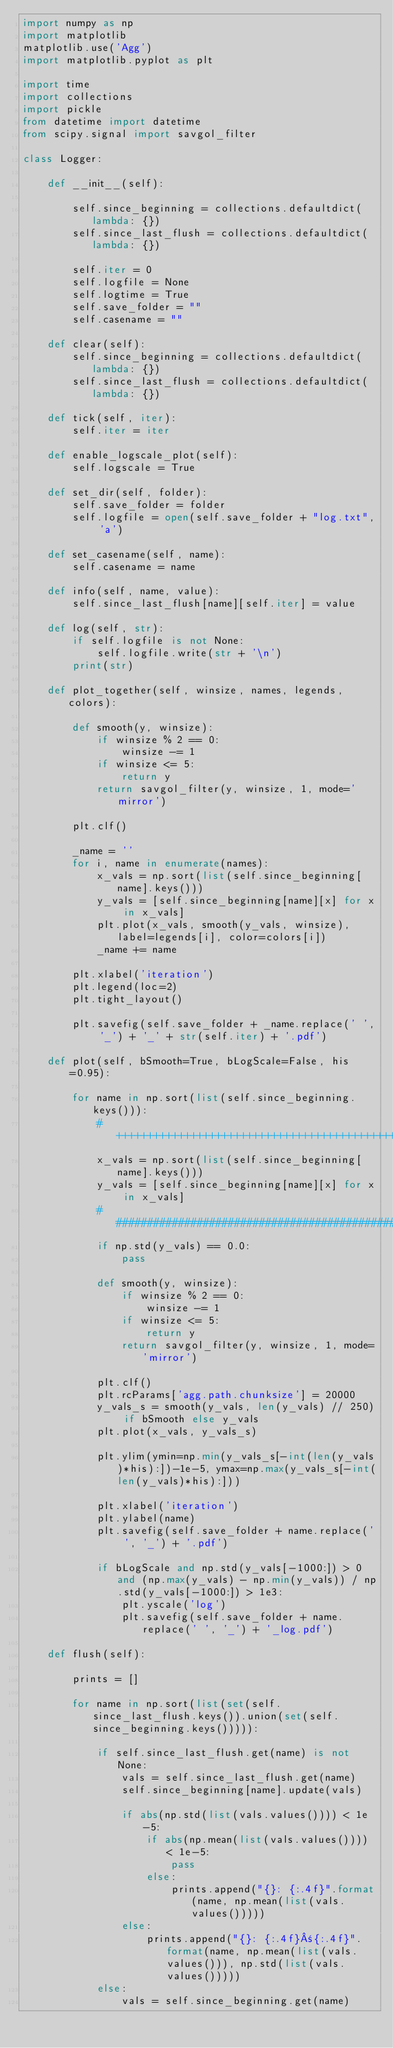<code> <loc_0><loc_0><loc_500><loc_500><_Python_>import numpy as np
import matplotlib
matplotlib.use('Agg')
import matplotlib.pyplot as plt

import time
import collections
import pickle
from datetime import datetime
from scipy.signal import savgol_filter

class Logger:

    def __init__(self):

        self.since_beginning = collections.defaultdict(lambda: {})
        self.since_last_flush = collections.defaultdict(lambda: {})

        self.iter = 0
        self.logfile = None
        self.logtime = True
        self.save_folder = ""
        self.casename = ""

    def clear(self):
        self.since_beginning = collections.defaultdict(lambda: {})
        self.since_last_flush = collections.defaultdict(lambda: {})

    def tick(self, iter):
        self.iter = iter

    def enable_logscale_plot(self):
        self.logscale = True

    def set_dir(self, folder):
        self.save_folder = folder
        self.logfile = open(self.save_folder + "log.txt", 'a')

    def set_casename(self, name):
        self.casename = name

    def info(self, name, value):
        self.since_last_flush[name][self.iter] = value

    def log(self, str):
        if self.logfile is not None:
            self.logfile.write(str + '\n')
        print(str)

    def plot_together(self, winsize, names, legends, colors):

        def smooth(y, winsize):
            if winsize % 2 == 0:
                winsize -= 1
            if winsize <= 5:
                return y
            return savgol_filter(y, winsize, 1, mode='mirror')

        plt.clf()

        _name = ''
        for i, name in enumerate(names):
            x_vals = np.sort(list(self.since_beginning[name].keys()))
            y_vals = [self.since_beginning[name][x] for x in x_vals]
            plt.plot(x_vals, smooth(y_vals, winsize), label=legends[i], color=colors[i])
            _name += name

        plt.xlabel('iteration')
        plt.legend(loc=2)
        plt.tight_layout()

        plt.savefig(self.save_folder + _name.replace(' ', '_') + '_' + str(self.iter) + '.pdf')

    def plot(self, bSmooth=True, bLogScale=False, his=0.95):

        for name in np.sort(list(self.since_beginning.keys())):
            #++++++++++++++++++++++++++++++++++++++++++++++++++++++++
            x_vals = np.sort(list(self.since_beginning[name].keys()))
            y_vals = [self.since_beginning[name][x] for x in x_vals]
            #########################################################
            if np.std(y_vals) == 0.0:
                pass

            def smooth(y, winsize):
                if winsize % 2 == 0:
                    winsize -= 1
                if winsize <= 5:
                    return y
                return savgol_filter(y, winsize, 1, mode='mirror')

            plt.clf()
            plt.rcParams['agg.path.chunksize'] = 20000
            y_vals_s = smooth(y_vals, len(y_vals) // 250) if bSmooth else y_vals
            plt.plot(x_vals, y_vals_s)

            plt.ylim(ymin=np.min(y_vals_s[-int(len(y_vals)*his):])-1e-5, ymax=np.max(y_vals_s[-int(len(y_vals)*his):]))

            plt.xlabel('iteration')
            plt.ylabel(name)
            plt.savefig(self.save_folder + name.replace(' ', '_') + '.pdf')

            if bLogScale and np.std(y_vals[-1000:]) > 0 and (np.max(y_vals) - np.min(y_vals)) / np.std(y_vals[-1000:]) > 1e3:
                plt.yscale('log')
                plt.savefig(self.save_folder + name.replace(' ', '_') + '_log.pdf')

    def flush(self):

        prints = []

        for name in np.sort(list(set(self.since_last_flush.keys()).union(set(self.since_beginning.keys())))):

            if self.since_last_flush.get(name) is not None:
                vals = self.since_last_flush.get(name)
                self.since_beginning[name].update(vals)

                if abs(np.std(list(vals.values()))) < 1e-5:
                    if abs(np.mean(list(vals.values()))) < 1e-5:
                        pass
                    else:
                        prints.append("{}: {:.4f}".format(name, np.mean(list(vals.values()))))
                else:
                    prints.append("{}: {:.4f}±{:.4f}".format(name, np.mean(list(vals.values())), np.std(list(vals.values()))))
            else:
                vals = self.since_beginning.get(name)</code> 